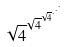Convert formula to latex. <formula><loc_0><loc_0><loc_500><loc_500>\sqrt { 4 } ^ { \sqrt { 4 } ^ { \sqrt { 4 } ^ { \cdot ^ { \cdot ^ { \cdot } } } } }</formula> 